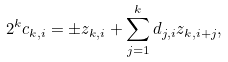<formula> <loc_0><loc_0><loc_500><loc_500>2 ^ { k } c _ { k , i } = \pm z _ { k , i } + \sum _ { j = 1 } ^ { k } d _ { j , i } z _ { k , i + j } ,</formula> 